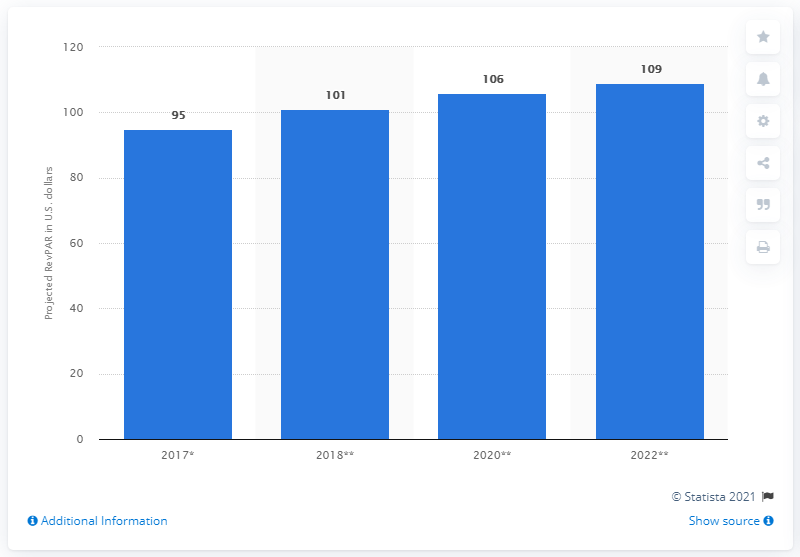Draw attention to some important aspects in this diagram. The revenue per available room forecast for the GCC region was expected to be 109 by 2022. 